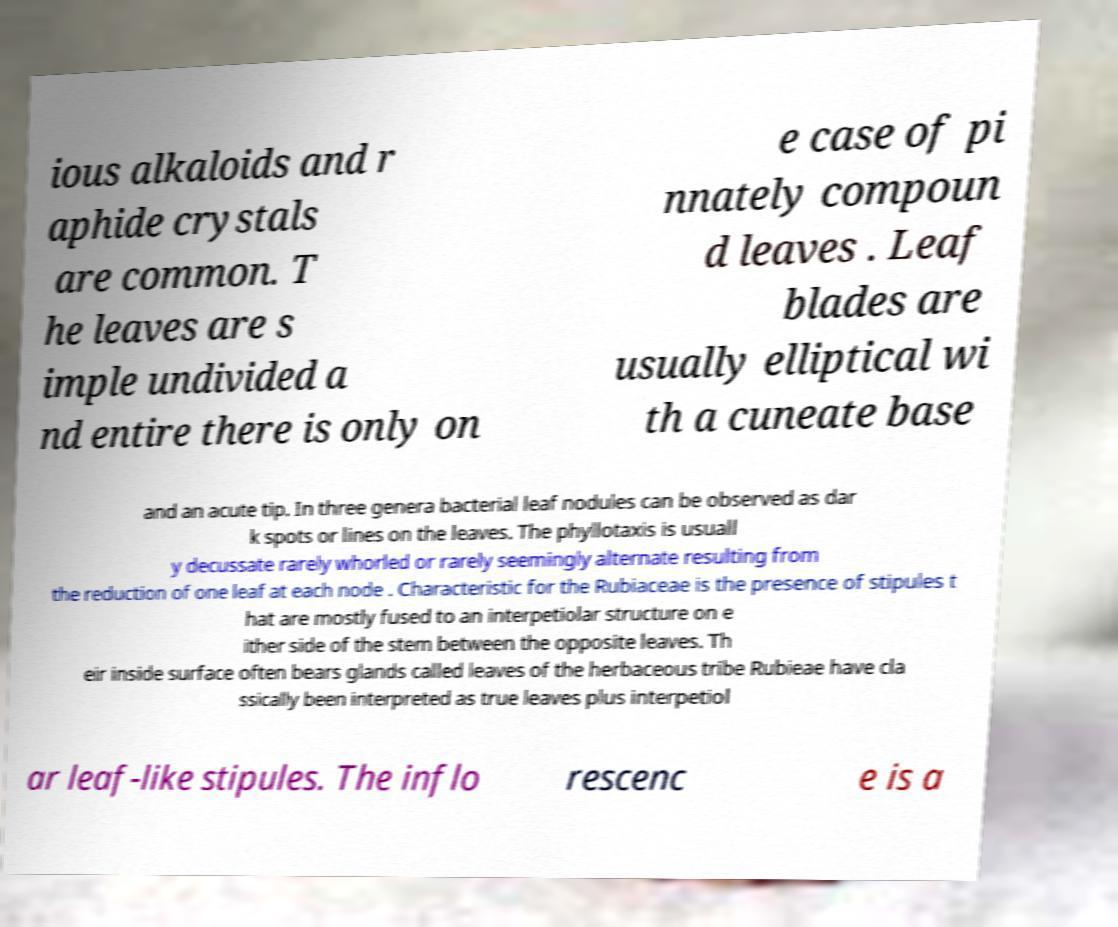Could you assist in decoding the text presented in this image and type it out clearly? ious alkaloids and r aphide crystals are common. T he leaves are s imple undivided a nd entire there is only on e case of pi nnately compoun d leaves . Leaf blades are usually elliptical wi th a cuneate base and an acute tip. In three genera bacterial leaf nodules can be observed as dar k spots or lines on the leaves. The phyllotaxis is usuall y decussate rarely whorled or rarely seemingly alternate resulting from the reduction of one leaf at each node . Characteristic for the Rubiaceae is the presence of stipules t hat are mostly fused to an interpetiolar structure on e ither side of the stem between the opposite leaves. Th eir inside surface often bears glands called leaves of the herbaceous tribe Rubieae have cla ssically been interpreted as true leaves plus interpetiol ar leaf-like stipules. The inflo rescenc e is a 